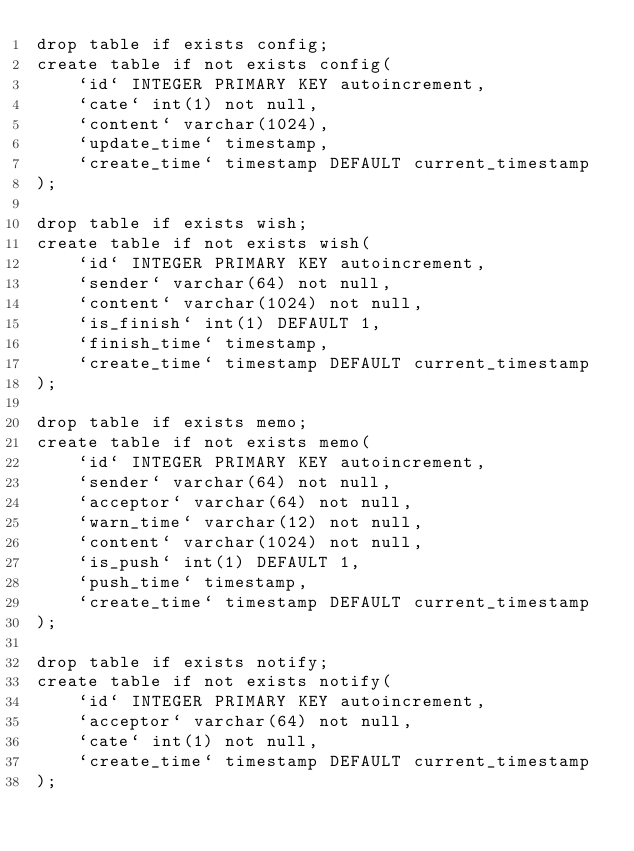Convert code to text. <code><loc_0><loc_0><loc_500><loc_500><_SQL_>drop table if exists config;
create table if not exists config(
    `id` INTEGER PRIMARY KEY autoincrement,
    `cate` int(1) not null,
    `content` varchar(1024),
    `update_time` timestamp,
    `create_time` timestamp DEFAULT current_timestamp
);

drop table if exists wish;
create table if not exists wish(
    `id` INTEGER PRIMARY KEY autoincrement,
    `sender` varchar(64) not null,
    `content` varchar(1024) not null,
    `is_finish` int(1) DEFAULT 1,
    `finish_time` timestamp,
    `create_time` timestamp DEFAULT current_timestamp
);

drop table if exists memo;
create table if not exists memo(
    `id` INTEGER PRIMARY KEY autoincrement,
    `sender` varchar(64) not null,
    `acceptor` varchar(64) not null,
    `warn_time` varchar(12) not null,
    `content` varchar(1024) not null,
    `is_push` int(1) DEFAULT 1,
    `push_time` timestamp,
    `create_time` timestamp DEFAULT current_timestamp
);

drop table if exists notify;
create table if not exists notify(
    `id` INTEGER PRIMARY KEY autoincrement,
    `acceptor` varchar(64) not null,
    `cate` int(1) not null,
    `create_time` timestamp DEFAULT current_timestamp
);</code> 